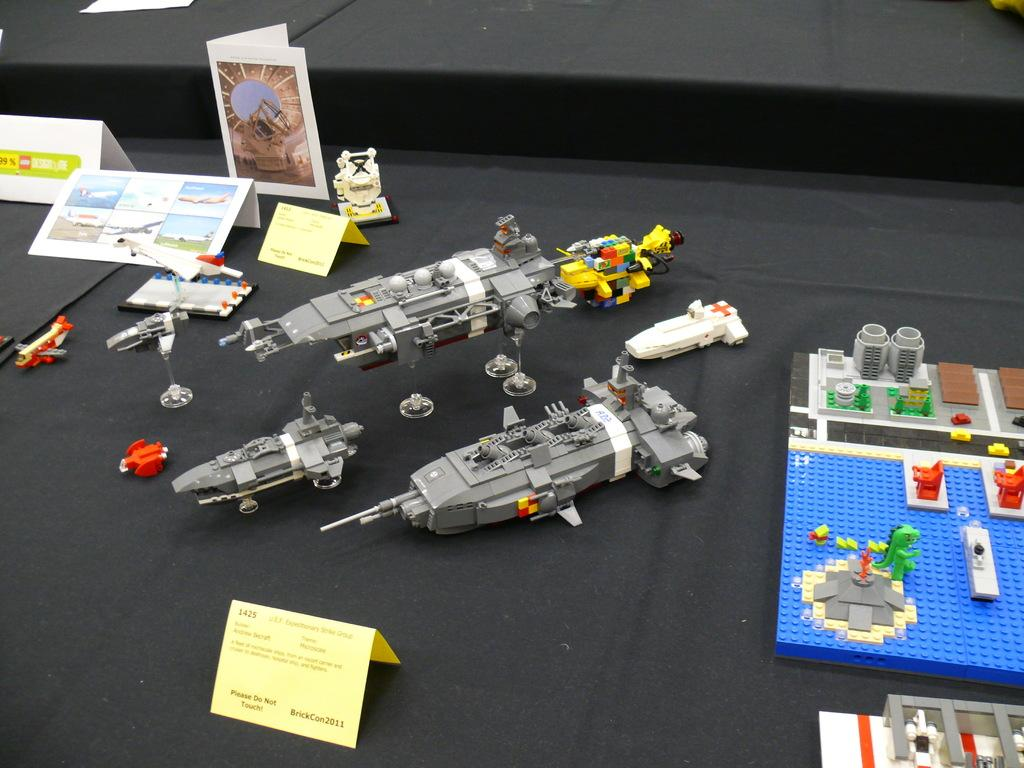What type of objects can be seen in the image? There are toys and paper cuttings in the image. What is the color of the surface in the image? The surface in the image is black in color. What type of town is depicted in the image? There is no town present in the image; it features toys and paper cuttings on a black surface. Can you tell me how many people are involved in an argument in the image? There are no people or arguments present in the image. 